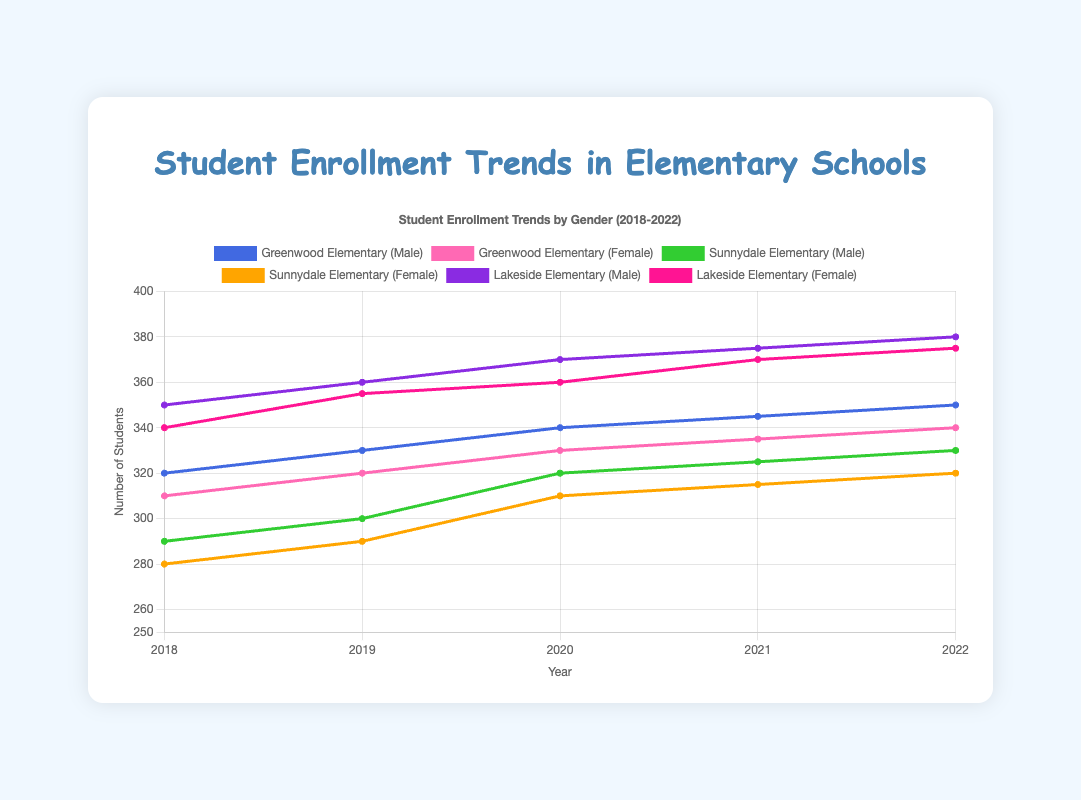What is the trend in male enrollment at Greenwood Elementary from 2018 to 2022? To determine the trend, look at the data points for each year for Greenwood Elementary's male enrollment and observe whether the numbers are increasing, decreasing, or remaining stable. The male enrollment numbers for Greenwood Elementary are 320 in 2018, 330 in 2019, 340 in 2020, 345 in 2021, and 350 in 2022. Since the numbers are increasing each year, the trend is upward.
Answer: Increasing Compare the male and female enrollment at Lakeside Elementary in 2020. Which gender had higher enrollment and by how much? Look at the enrollment data for Lakeside Elementary in 2020: male enrollment is 370 and female enrollment is 360. The difference between the enrollments is 370 - 360 = 10. Therefore, male enrollment was higher by 10 students.
Answer: Male by 10 Which school had the highest female enrollment in 2021? To find the school with the highest female enrollment in 2021, compare the female enrollment numbers for each school: Greenwood Elementary (335), Sunnydale Elementary (315), and Lakeside Elementary (370). The highest number is 370 at Lakeside Elementary.
Answer: Lakeside Elementary What was the total student enrollment at Sunnydale Elementary in 2019? To find the total enrollment, sum the male and female enrollments at Sunnydale Elementary in 2019: 300 (male) + 290 (female) = 590.
Answer: 590 Calculate the average male enrollment across all schools in 2018. First, sum the male enrollments for each school in 2018: 320 (Greenwood Elementary) + 290 (Sunnydale Elementary) + 350 (Lakeside Elementary) = 960. Then, divide by the number of schools (3). 960 / 3 = 320.
Answer: 320 How did the total enrollment at Greenwood Elementary change from 2018 to 2022? Calculate the total enrollment for each year by summing the male and female enrollments: 2018 (320+310 = 630), 2022 (350+340 = 690). The change in enrollment is 690 - 630 = 60.
Answer: Increased by 60 Which school had the smallest increase in male enrollment from 2020 to 2021? Compare the increase in male enrollment for each school: Greenwood Elementary (345-340 = 5), Sunnydale Elementary (325-320 = 5), Lakeside Elementary (375-370 = 5). All schools had the same increase of 5.
Answer: All schools had the same increase (5) What is the average female enrollment at Lakeside Elementary over the years 2018-2022? Sum the enrollments for each year and then divide by the number of years: (340 + 355 + 360 + 370 + 375) / 5 = 1800 / 5 = 360.
Answer: 360 Compare the trend of male and female enrollments at Sunnydale Elementary from 2018 to 2022. Which gender showed a greater rate of increase? Observe the enrollments for both genders over the years: Male (290, 300, 320, 325, 330) and Female (280, 290, 310, 315, 320). Calculate the total increase: Male (330 - 290 = 40) and Female (320 - 280 = 40). Both genders had the same increase of 40.
Answer: Same rate of increase In 2022, which school had the closest male to female enrollment ratio? Examine the male to female enrollment for each school in 2022: Greenwood Elementary (350/340 = 1.03), Sunnydale Elementary (330/320 = 1.03), and Lakeside Elementary (380/375 = 1.01). Lakeside Elementary has the closest ratio of 1.01.
Answer: Lakeside Elementary 